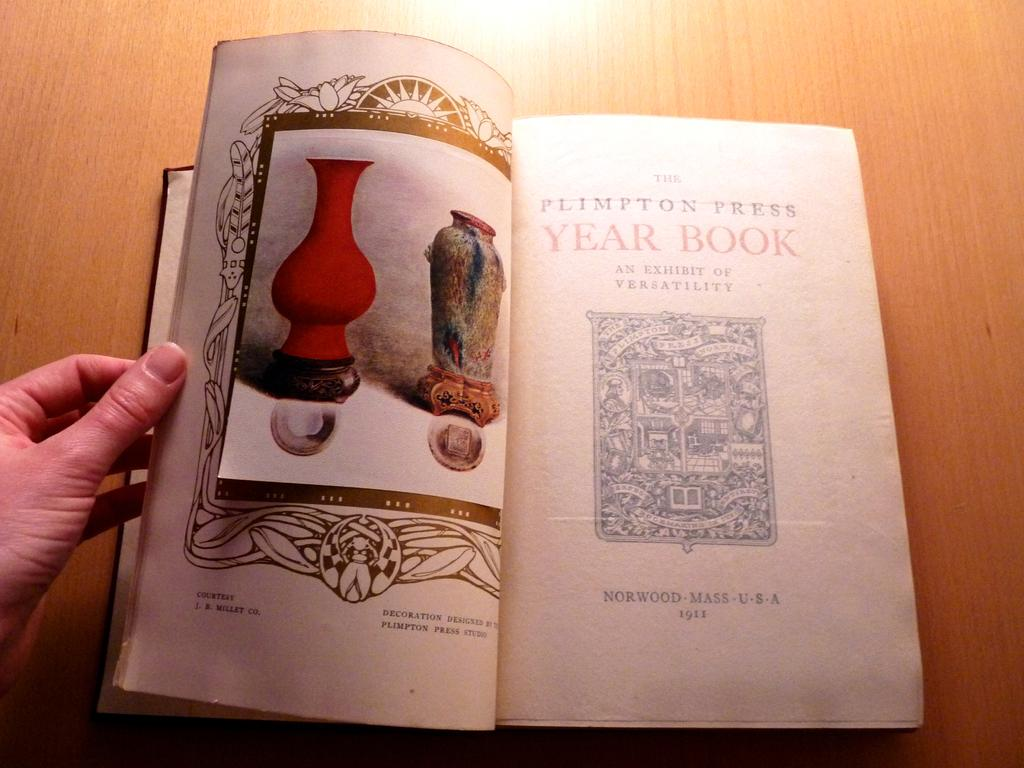<image>
Relay a brief, clear account of the picture shown. A person is flipping through a book by The Plimpton Press. 